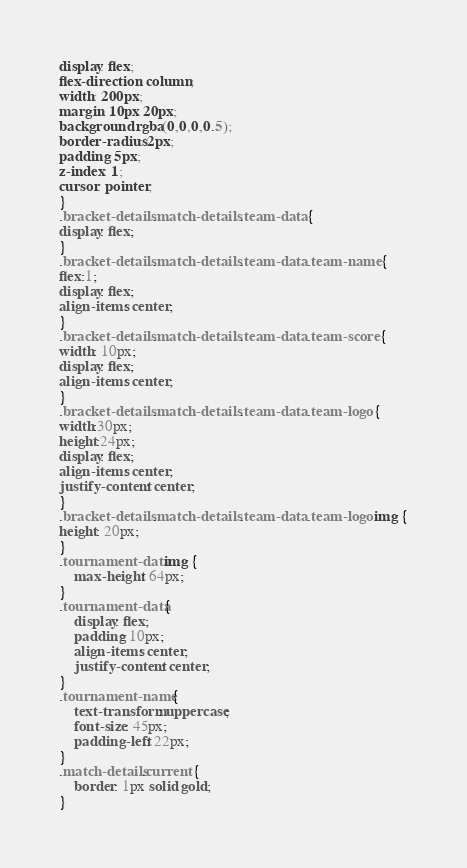<code> <loc_0><loc_0><loc_500><loc_500><_CSS_>display: flex;
flex-direction: column;
width: 200px;
margin: 10px 20px;
background: rgba(0,0,0,0.5);
border-radius: 2px;
padding: 5px;
z-index: 1;
cursor: pointer;
}
.bracket-details .match-details .team-data {
display: flex;
}
.bracket-details .match-details .team-data .team-name {
flex:1;
display: flex;
align-items: center;
}
.bracket-details .match-details .team-data .team-score {
width: 10px; 
display: flex;
align-items: center;
}
.bracket-details .match-details .team-data .team-logo {
width:30px;
height:24px;
display: flex;
align-items: center;
justify-content: center;
}
.bracket-details .match-details .team-data .team-logo img {
height: 20px;
}
.tournament-data img {
    max-height: 64px;
}
.tournament-data {
    display: flex;
    padding: 10px;
    align-items: center;
    justify-content: center;
}
.tournament-name {
    text-transform: uppercase;
    font-size: 45px;
    padding-left: 22px;
}
.match-details.current {
    border: 1px solid gold;
}</code> 